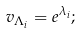Convert formula to latex. <formula><loc_0><loc_0><loc_500><loc_500>v _ { \Lambda _ { i } } = e ^ { \lambda _ { i } } ;</formula> 